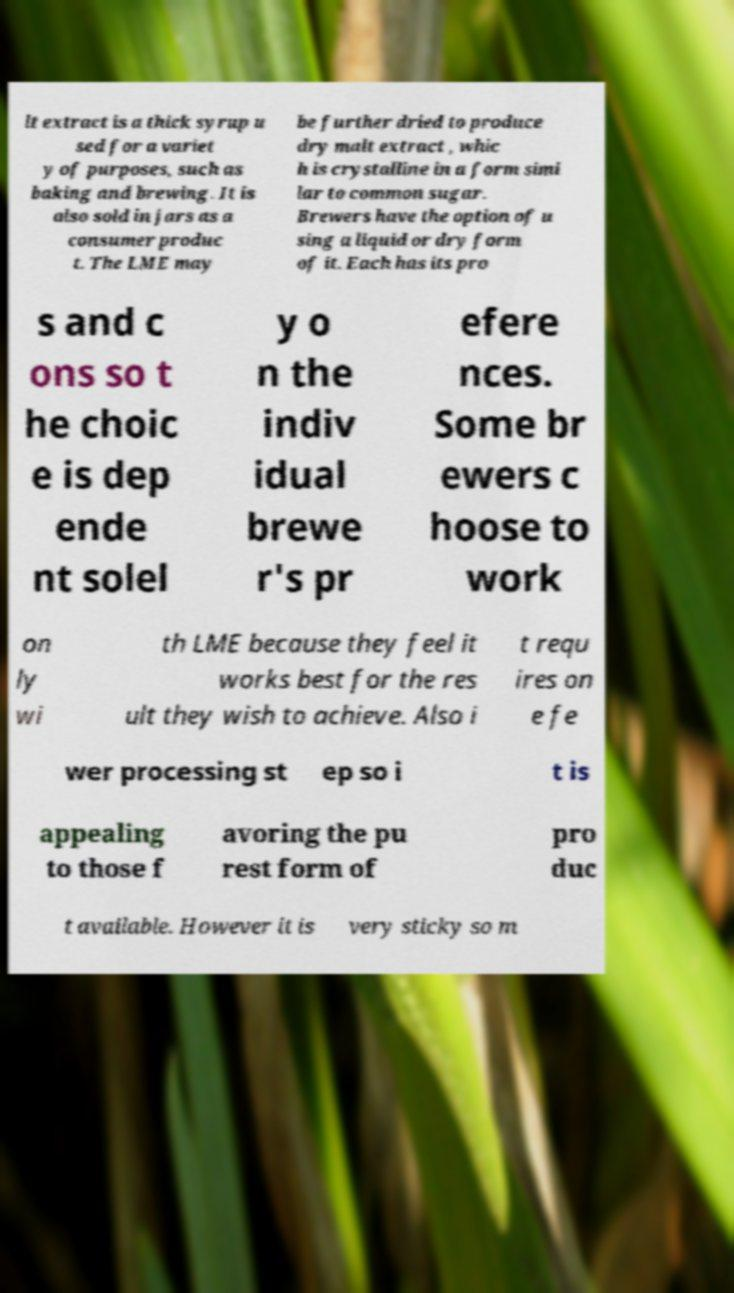Could you assist in decoding the text presented in this image and type it out clearly? lt extract is a thick syrup u sed for a variet y of purposes, such as baking and brewing. It is also sold in jars as a consumer produc t. The LME may be further dried to produce dry malt extract , whic h is crystalline in a form simi lar to common sugar. Brewers have the option of u sing a liquid or dry form of it. Each has its pro s and c ons so t he choic e is dep ende nt solel y o n the indiv idual brewe r's pr efere nces. Some br ewers c hoose to work on ly wi th LME because they feel it works best for the res ult they wish to achieve. Also i t requ ires on e fe wer processing st ep so i t is appealing to those f avoring the pu rest form of pro duc t available. However it is very sticky so m 